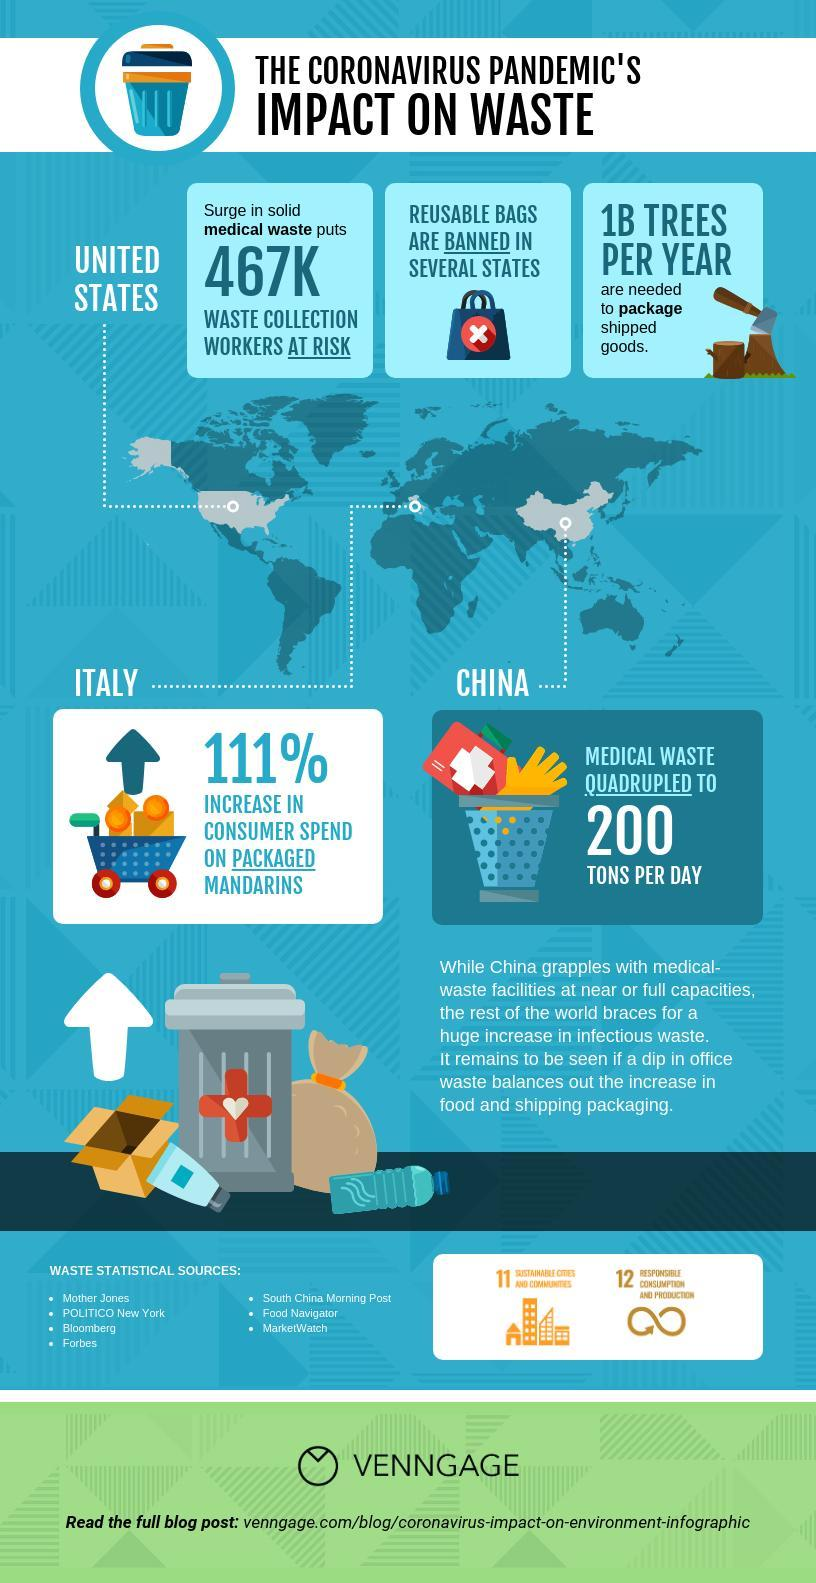How many waste statistical sources are given?
Answer the question with a short phrase. 7 